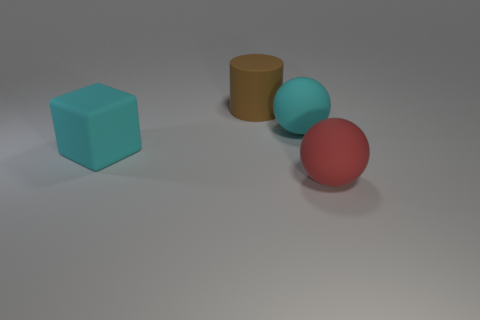How big is the rubber sphere that is behind the rubber object that is left of the large cylinder?
Provide a short and direct response. Large. Are there the same number of red objects that are behind the large block and cyan rubber objects behind the big brown object?
Your response must be concise. Yes. There is a object that is on the right side of the big brown object and behind the block; what is its material?
Provide a succinct answer. Rubber. There is a red object; does it have the same size as the cyan rubber thing that is behind the big cyan matte block?
Ensure brevity in your answer.  Yes. How many other things are there of the same color as the big rubber block?
Your answer should be compact. 1. Are there more red matte objects behind the large matte block than large red objects?
Provide a succinct answer. No. What color is the large matte object that is to the right of the sphere behind the big rubber object that is left of the big brown object?
Your answer should be very brief. Red. Is the cyan block made of the same material as the red object?
Make the answer very short. Yes. Are there any brown rubber cubes that have the same size as the red rubber thing?
Give a very brief answer. No. There is a cyan ball that is the same size as the block; what is it made of?
Give a very brief answer. Rubber. 